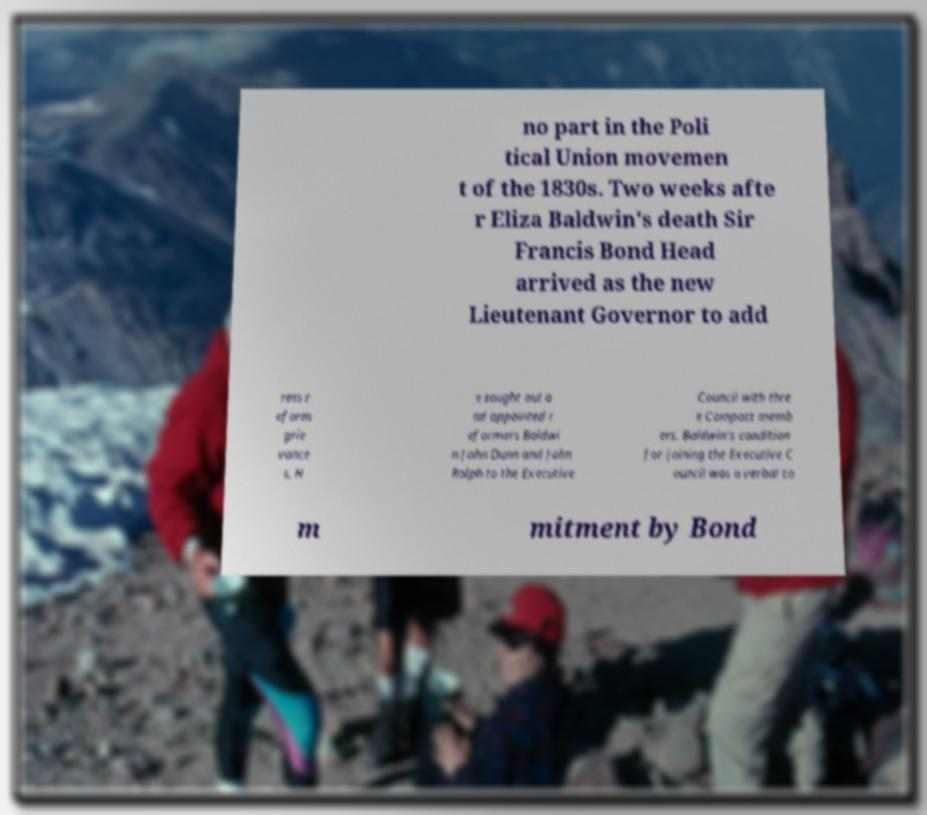What messages or text are displayed in this image? I need them in a readable, typed format. no part in the Poli tical Union movemen t of the 1830s. Two weeks afte r Eliza Baldwin's death Sir Francis Bond Head arrived as the new Lieutenant Governor to add ress r eform grie vance s. H e sought out a nd appointed r eformers Baldwi n John Dunn and John Rolph to the Executive Council with thre e Compact memb ers. Baldwin's condition for joining the Executive C ouncil was a verbal co m mitment by Bond 